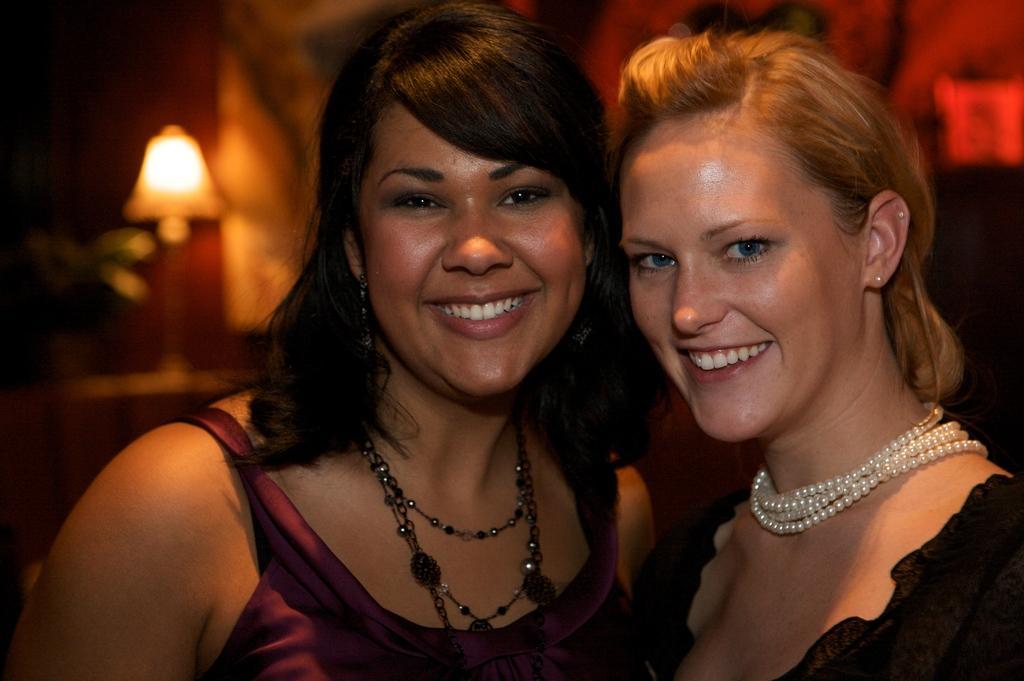Could you give a brief overview of what you see in this image? In this picture there are two women smiling. In the background of the image it is blurry and we can see lamp. 